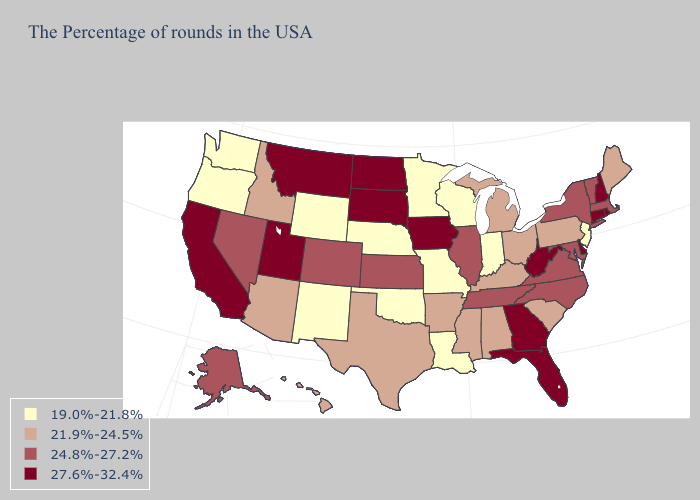Among the states that border Ohio , does Indiana have the lowest value?
Short answer required. Yes. Name the states that have a value in the range 21.9%-24.5%?
Give a very brief answer. Maine, Pennsylvania, South Carolina, Ohio, Michigan, Kentucky, Alabama, Mississippi, Arkansas, Texas, Arizona, Idaho, Hawaii. Does New Hampshire have a higher value than Delaware?
Short answer required. No. Does New York have a lower value than Utah?
Write a very short answer. Yes. Does Georgia have the highest value in the South?
Be succinct. Yes. Name the states that have a value in the range 19.0%-21.8%?
Keep it brief. New Jersey, Indiana, Wisconsin, Louisiana, Missouri, Minnesota, Nebraska, Oklahoma, Wyoming, New Mexico, Washington, Oregon. Does Pennsylvania have a higher value than Missouri?
Short answer required. Yes. What is the value of Nebraska?
Concise answer only. 19.0%-21.8%. Name the states that have a value in the range 24.8%-27.2%?
Give a very brief answer. Massachusetts, Vermont, New York, Maryland, Virginia, North Carolina, Tennessee, Illinois, Kansas, Colorado, Nevada, Alaska. Which states hav the highest value in the Northeast?
Concise answer only. Rhode Island, New Hampshire, Connecticut. What is the value of Vermont?
Answer briefly. 24.8%-27.2%. Name the states that have a value in the range 24.8%-27.2%?
Answer briefly. Massachusetts, Vermont, New York, Maryland, Virginia, North Carolina, Tennessee, Illinois, Kansas, Colorado, Nevada, Alaska. What is the value of Virginia?
Write a very short answer. 24.8%-27.2%. Does Wyoming have the lowest value in the West?
Short answer required. Yes. Does Kentucky have a lower value than South Dakota?
Quick response, please. Yes. 